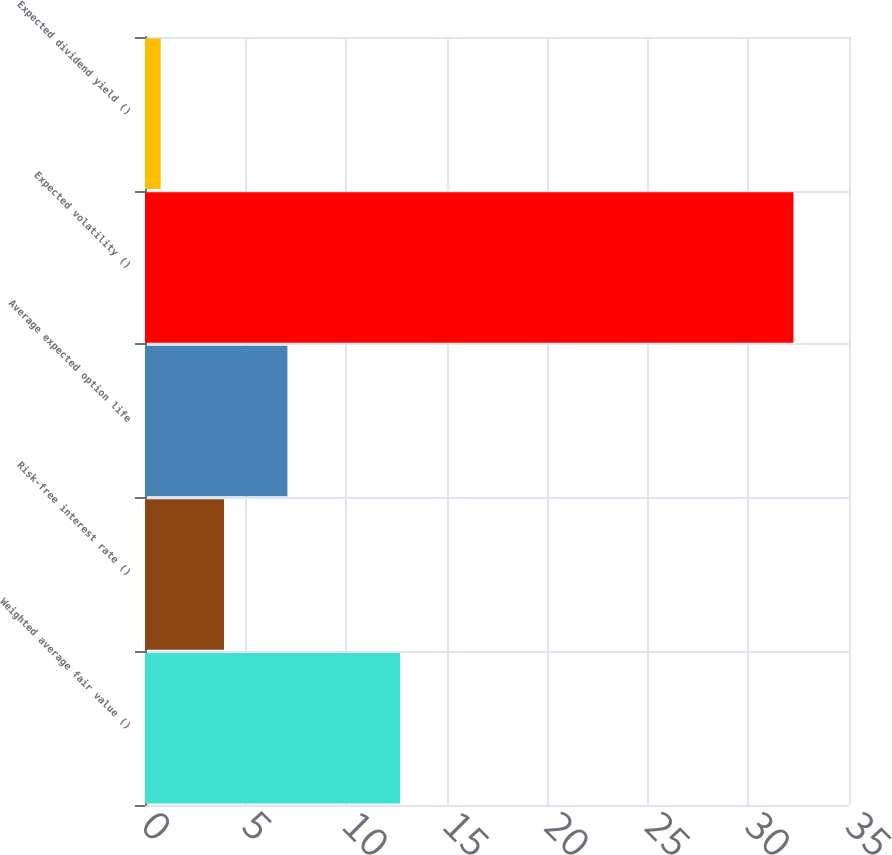Convert chart. <chart><loc_0><loc_0><loc_500><loc_500><bar_chart><fcel>Weighted average fair value ()<fcel>Risk-free interest rate ()<fcel>Average expected option life<fcel>Expected volatility ()<fcel>Expected dividend yield ()<nl><fcel>12.68<fcel>3.93<fcel>7.08<fcel>32.24<fcel>0.78<nl></chart> 